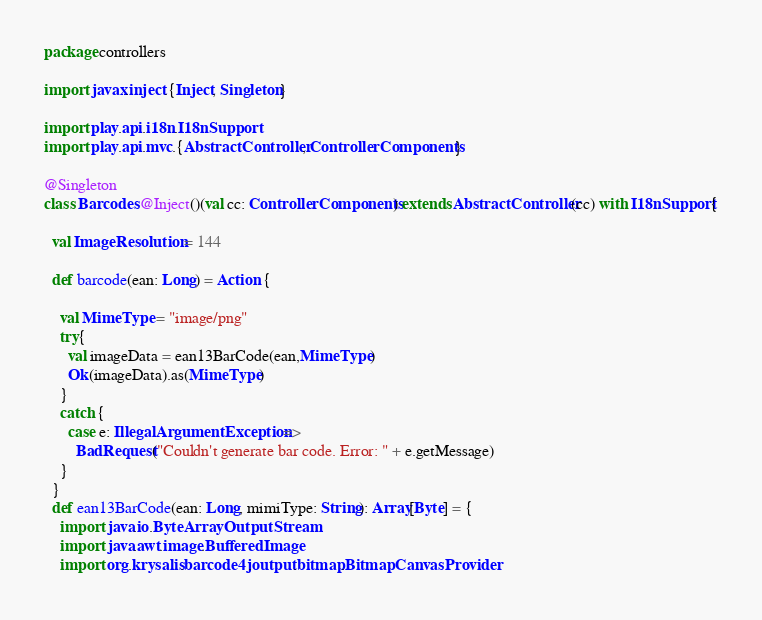Convert code to text. <code><loc_0><loc_0><loc_500><loc_500><_Scala_>package controllers

import javax.inject.{Inject, Singleton}

import play.api.i18n.I18nSupport
import play.api.mvc.{AbstractController, ControllerComponents}

@Singleton
class Barcodes @Inject()(val cc: ControllerComponents) extends AbstractController(cc) with I18nSupport{

  val ImageResolution = 144

  def barcode(ean: Long) = Action {

    val MimeType = "image/png"
    try{
      val imageData = ean13BarCode(ean,MimeType)
      Ok(imageData).as(MimeType)
    }
    catch {
      case e: IllegalArgumentException =>
        BadRequest("Couldn't generate bar code. Error: " + e.getMessage)
    }
  }
  def ean13BarCode(ean: Long, mimiType: String): Array[Byte] = {
    import java.io.ByteArrayOutputStream
    import java.awt.image.BufferedImage
    import org.krysalis.barcode4j.output.bitmap.BitmapCanvasProvider</code> 